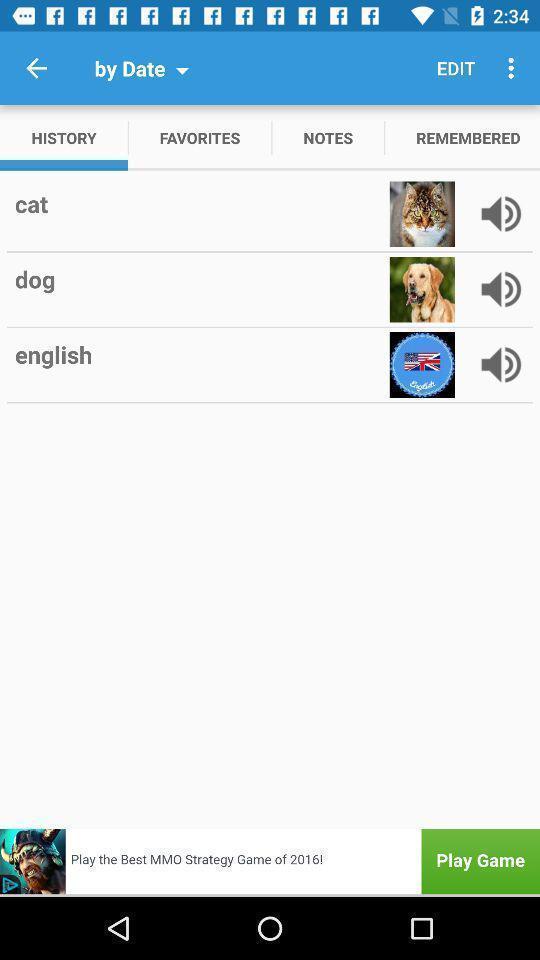Describe this image in words. Translate page. 